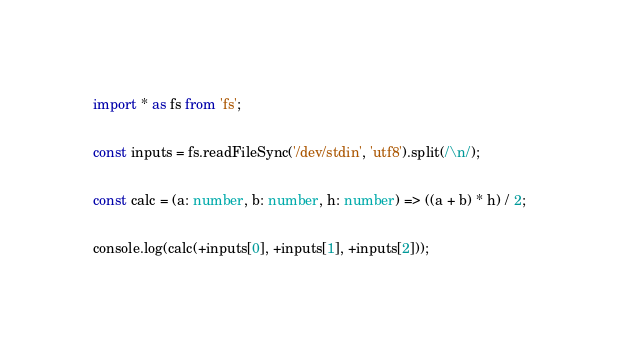Convert code to text. <code><loc_0><loc_0><loc_500><loc_500><_TypeScript_>import * as fs from 'fs';

const inputs = fs.readFileSync('/dev/stdin', 'utf8').split(/\n/);

const calc = (a: number, b: number, h: number) => ((a + b) * h) / 2;

console.log(calc(+inputs[0], +inputs[1], +inputs[2]));
</code> 